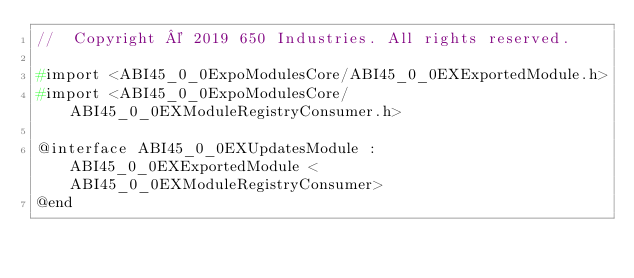<code> <loc_0><loc_0><loc_500><loc_500><_C_>//  Copyright © 2019 650 Industries. All rights reserved.

#import <ABI45_0_0ExpoModulesCore/ABI45_0_0EXExportedModule.h>
#import <ABI45_0_0ExpoModulesCore/ABI45_0_0EXModuleRegistryConsumer.h>

@interface ABI45_0_0EXUpdatesModule : ABI45_0_0EXExportedModule <ABI45_0_0EXModuleRegistryConsumer>
@end
</code> 